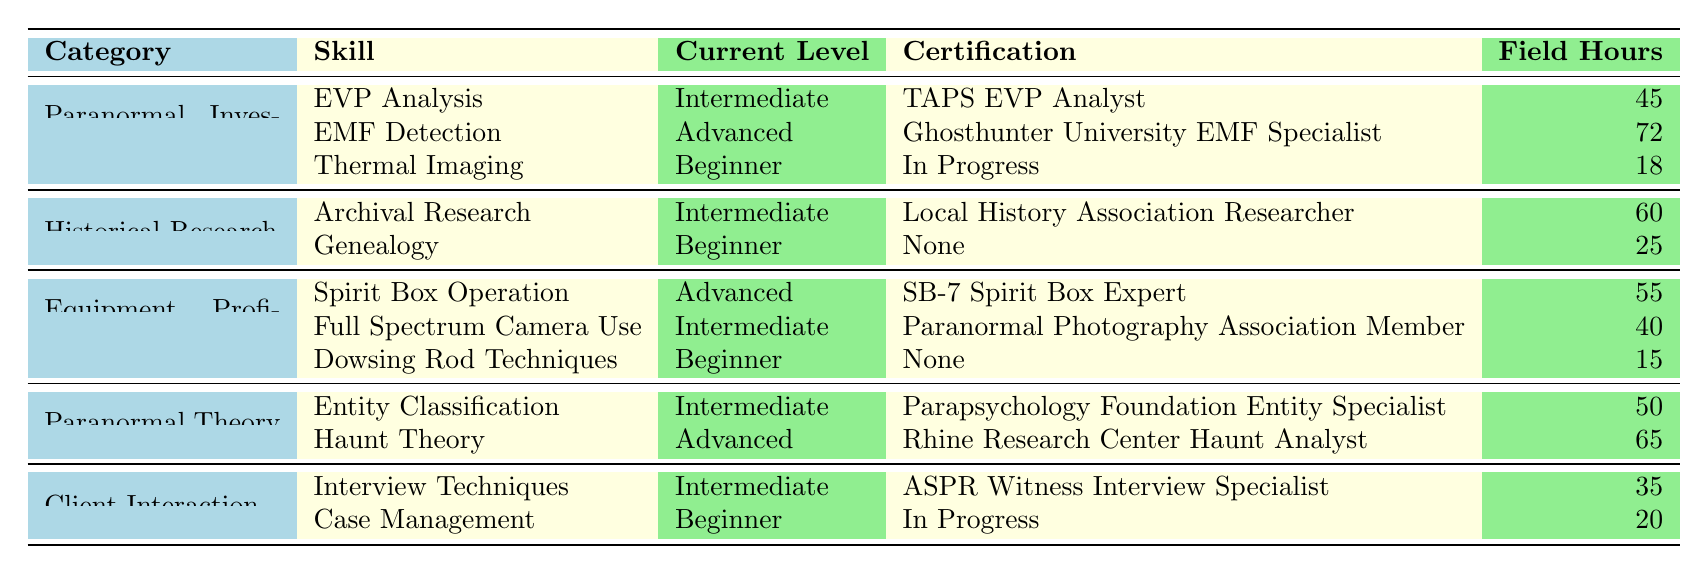What is the highest skill level attained in Paranormal Investigation Skills? The table shows that the highest skill level in the "Paranormal Investigation Skills" category is "Advanced," which is attained in the "EMF Detection" skill.
Answer: Advanced How many total field experience hours are logged in Historical Research? The total field experience hours for "Historical Research" can be calculated by adding 60 hours (Archival Research) and 25 hours (Genealogy), resulting in 60 + 25 = 85 hours.
Answer: 85 Is there a certification listed for Genealogy? According to the table, "Genealogy" has no certification listed, indicating that the certification status is "None."
Answer: No What is the average number of field experience hours across all categories? To find the average, sum the hours: 45 + 72 + 18 (Paranormal Investigation Skills) + 60 + 25 (Historical Research) + 55 + 40 + 15 (Equipment Proficiency) + 50 + 65 (Paranormal Theory) + 35 + 20 (Client Interaction) =  45 + 72 + 18 + 60 + 25 + 55 + 40 + 15 + 50 + 65 + 35 + 20 =  455. There are 12 skills total, so the average is 455/12 ≈ 37.92 hours.
Answer: Approximately 37.92 What percentage of skills under Equipment Proficiency are at the Advanced level? There are 3 skills in total under "Equipment Proficiency": Spirit Box Operation (Advanced), Full Spectrum Camera Use (Intermediate), and Dowsing Rod Techniques (Beginner). Only 1 skill is Advanced out of 3, so the percentage is (1/3) × 100 = 33.33%.
Answer: 33.33% Which category has the most skills listed? By examining the table, "Paranormal Investigation Skills" and "Equipment Proficiency" both have 3 skills listed, while "Historical Research," "Paranormal Theory," and "Client Interaction" have 2 skills each. Therefore, the categories with the most skills listed are "Paranormal Investigation Skills" and "Equipment Proficiency."
Answer: Paranormal Investigation Skills and Equipment Proficiency 